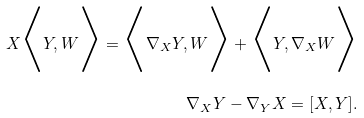<formula> <loc_0><loc_0><loc_500><loc_500>X \Big < Y , W \Big > = \Big < \nabla _ { X } Y , W \Big > + \Big < Y , \nabla _ { X } W \Big > \\ \nabla _ { X } Y - \nabla _ { Y } X = [ X , Y ] .</formula> 